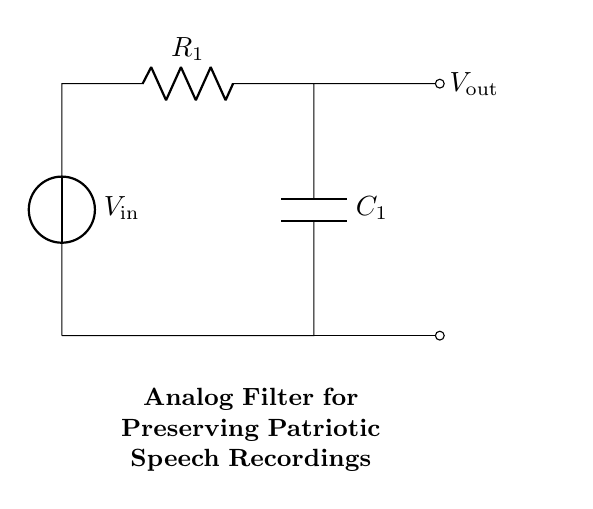What is the input voltage of the circuit? The input voltage is denoted as V_in in the circuit diagram, which represents the voltage supplied to the circuit.
Answer: V_in What type of components are in this circuit? The circuit consists of a resistor and a capacitor, identifiable by the symbols R and C in the schematic.
Answer: Resistor and Capacitor Which component preserves the essence of audio recordings? The circuit description highlights that the capacitor (C_1) is key in filtering, thus preserving audio quality.
Answer: Capacitor What is the output voltage's relation to the input? The output voltage, V_out, is taken across the capacitor and is influenced by the input voltage and RC time constant behavior.
Answer: V_out What happens if the resistor value increases? Increasing the resistor value (R_1) would result in a longer time constant, affecting the filtering properties and possibly altering how audio signals pass through.
Answer: Slower filtering What is the primary function of this analog filter circuit? The circuit's primary function is to filter audio signals to preserve the quality of patriotic speeches, effectively allowing desired frequencies to pass while attenuating others.
Answer: Audio filtering Which direction does the current flow in the circuit? Current flows from the input voltage source (V_in), through the resistor (R_1), into the capacitor (C_1), and back to ground, creating a loop.
Answer: Clockwise 